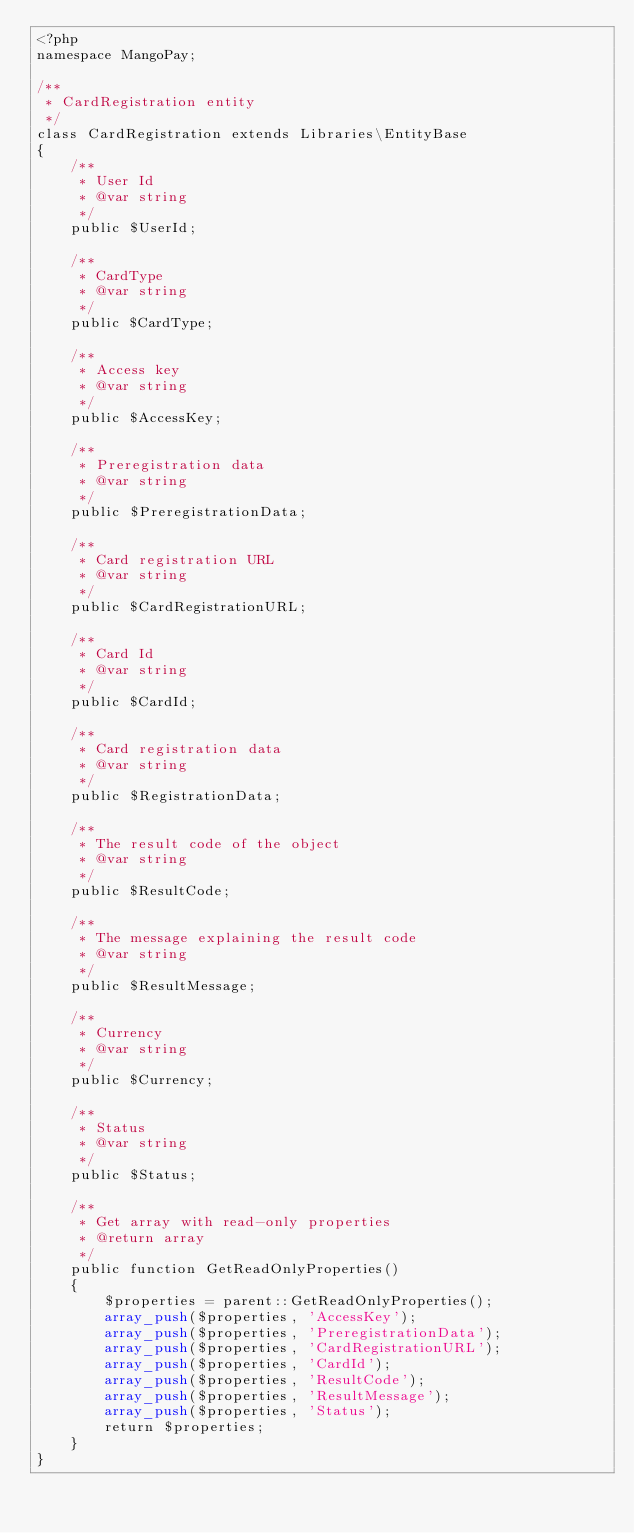Convert code to text. <code><loc_0><loc_0><loc_500><loc_500><_PHP_><?php
namespace MangoPay;

/**
 * CardRegistration entity
 */
class CardRegistration extends Libraries\EntityBase
{
    /**
     * User Id
     * @var string
     */
    public $UserId;
    
    /**
     * CardType
     * @var string
     */
    public $CardType;
    
    /**
     * Access key
     * @var string
     */
    public $AccessKey;
        
    /**
     * Preregistration data
     * @var string
     */
    public $PreregistrationData;
        
    /**
     * Card registration URL
     * @var string
     */
    public $CardRegistrationURL;
        
    /**
     * Card Id
     * @var string
     */
    public $CardId;
        
    /**
     * Card registration data
     * @var string
     */
    public $RegistrationData;
        
    /**
     * The result code of the object
     * @var string
     */
    public $ResultCode;
    
    /**
     * The message explaining the result code
     * @var string
     */
    public $ResultMessage;
        
    /**
     * Currency
     * @var string
     */
    public $Currency;
        
    /**
     * Status
     * @var string
     */
    public $Status;
        
    /**
     * Get array with read-only properties
     * @return array
     */
    public function GetReadOnlyProperties()
    {
        $properties = parent::GetReadOnlyProperties();
        array_push($properties, 'AccessKey');
        array_push($properties, 'PreregistrationData');
        array_push($properties, 'CardRegistrationURL');
        array_push($properties, 'CardId');
        array_push($properties, 'ResultCode');
        array_push($properties, 'ResultMessage');
        array_push($properties, 'Status');
        return $properties;
    }
}
</code> 